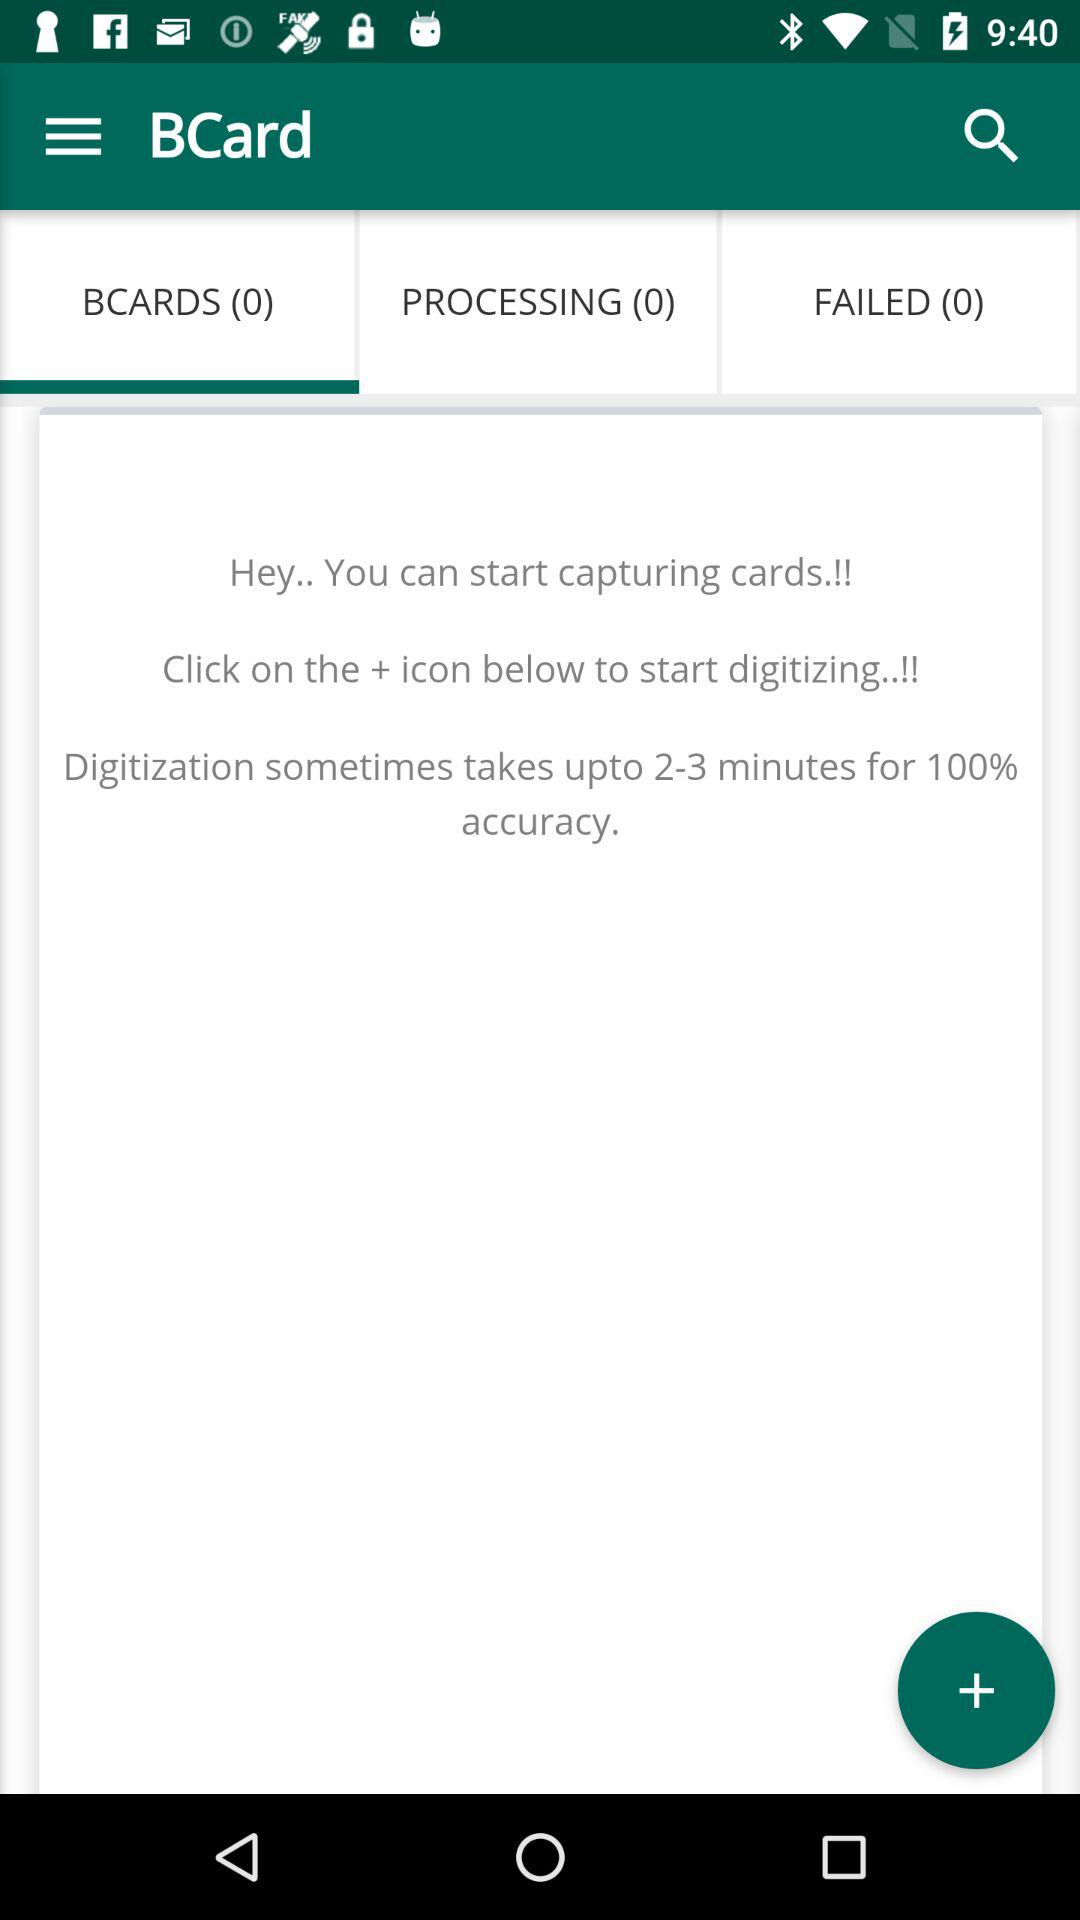How many "BCARDS" are there? There are 0 "BCARDS". 